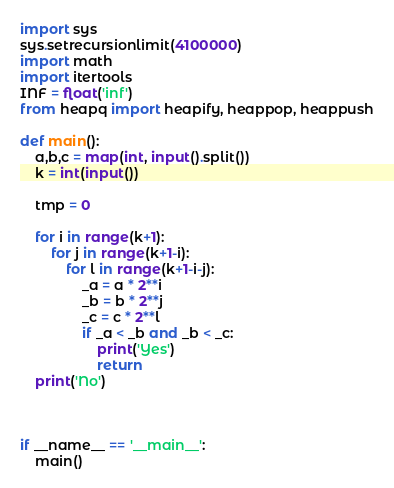<code> <loc_0><loc_0><loc_500><loc_500><_Python_>import sys
sys.setrecursionlimit(4100000)
import math
import itertools
INF = float('inf')
from heapq import heapify, heappop, heappush

def main():
    a,b,c = map(int, input().split())
    k = int(input())

    tmp = 0

    for i in range(k+1):
        for j in range(k+1-i):
            for l in range(k+1-i-j):
                _a = a * 2**i
                _b = b * 2**j
                _c = c * 2**l
                if _a < _b and _b < _c:
                    print('Yes')
                    return
    print('No')



if __name__ == '__main__':
    main()
</code> 